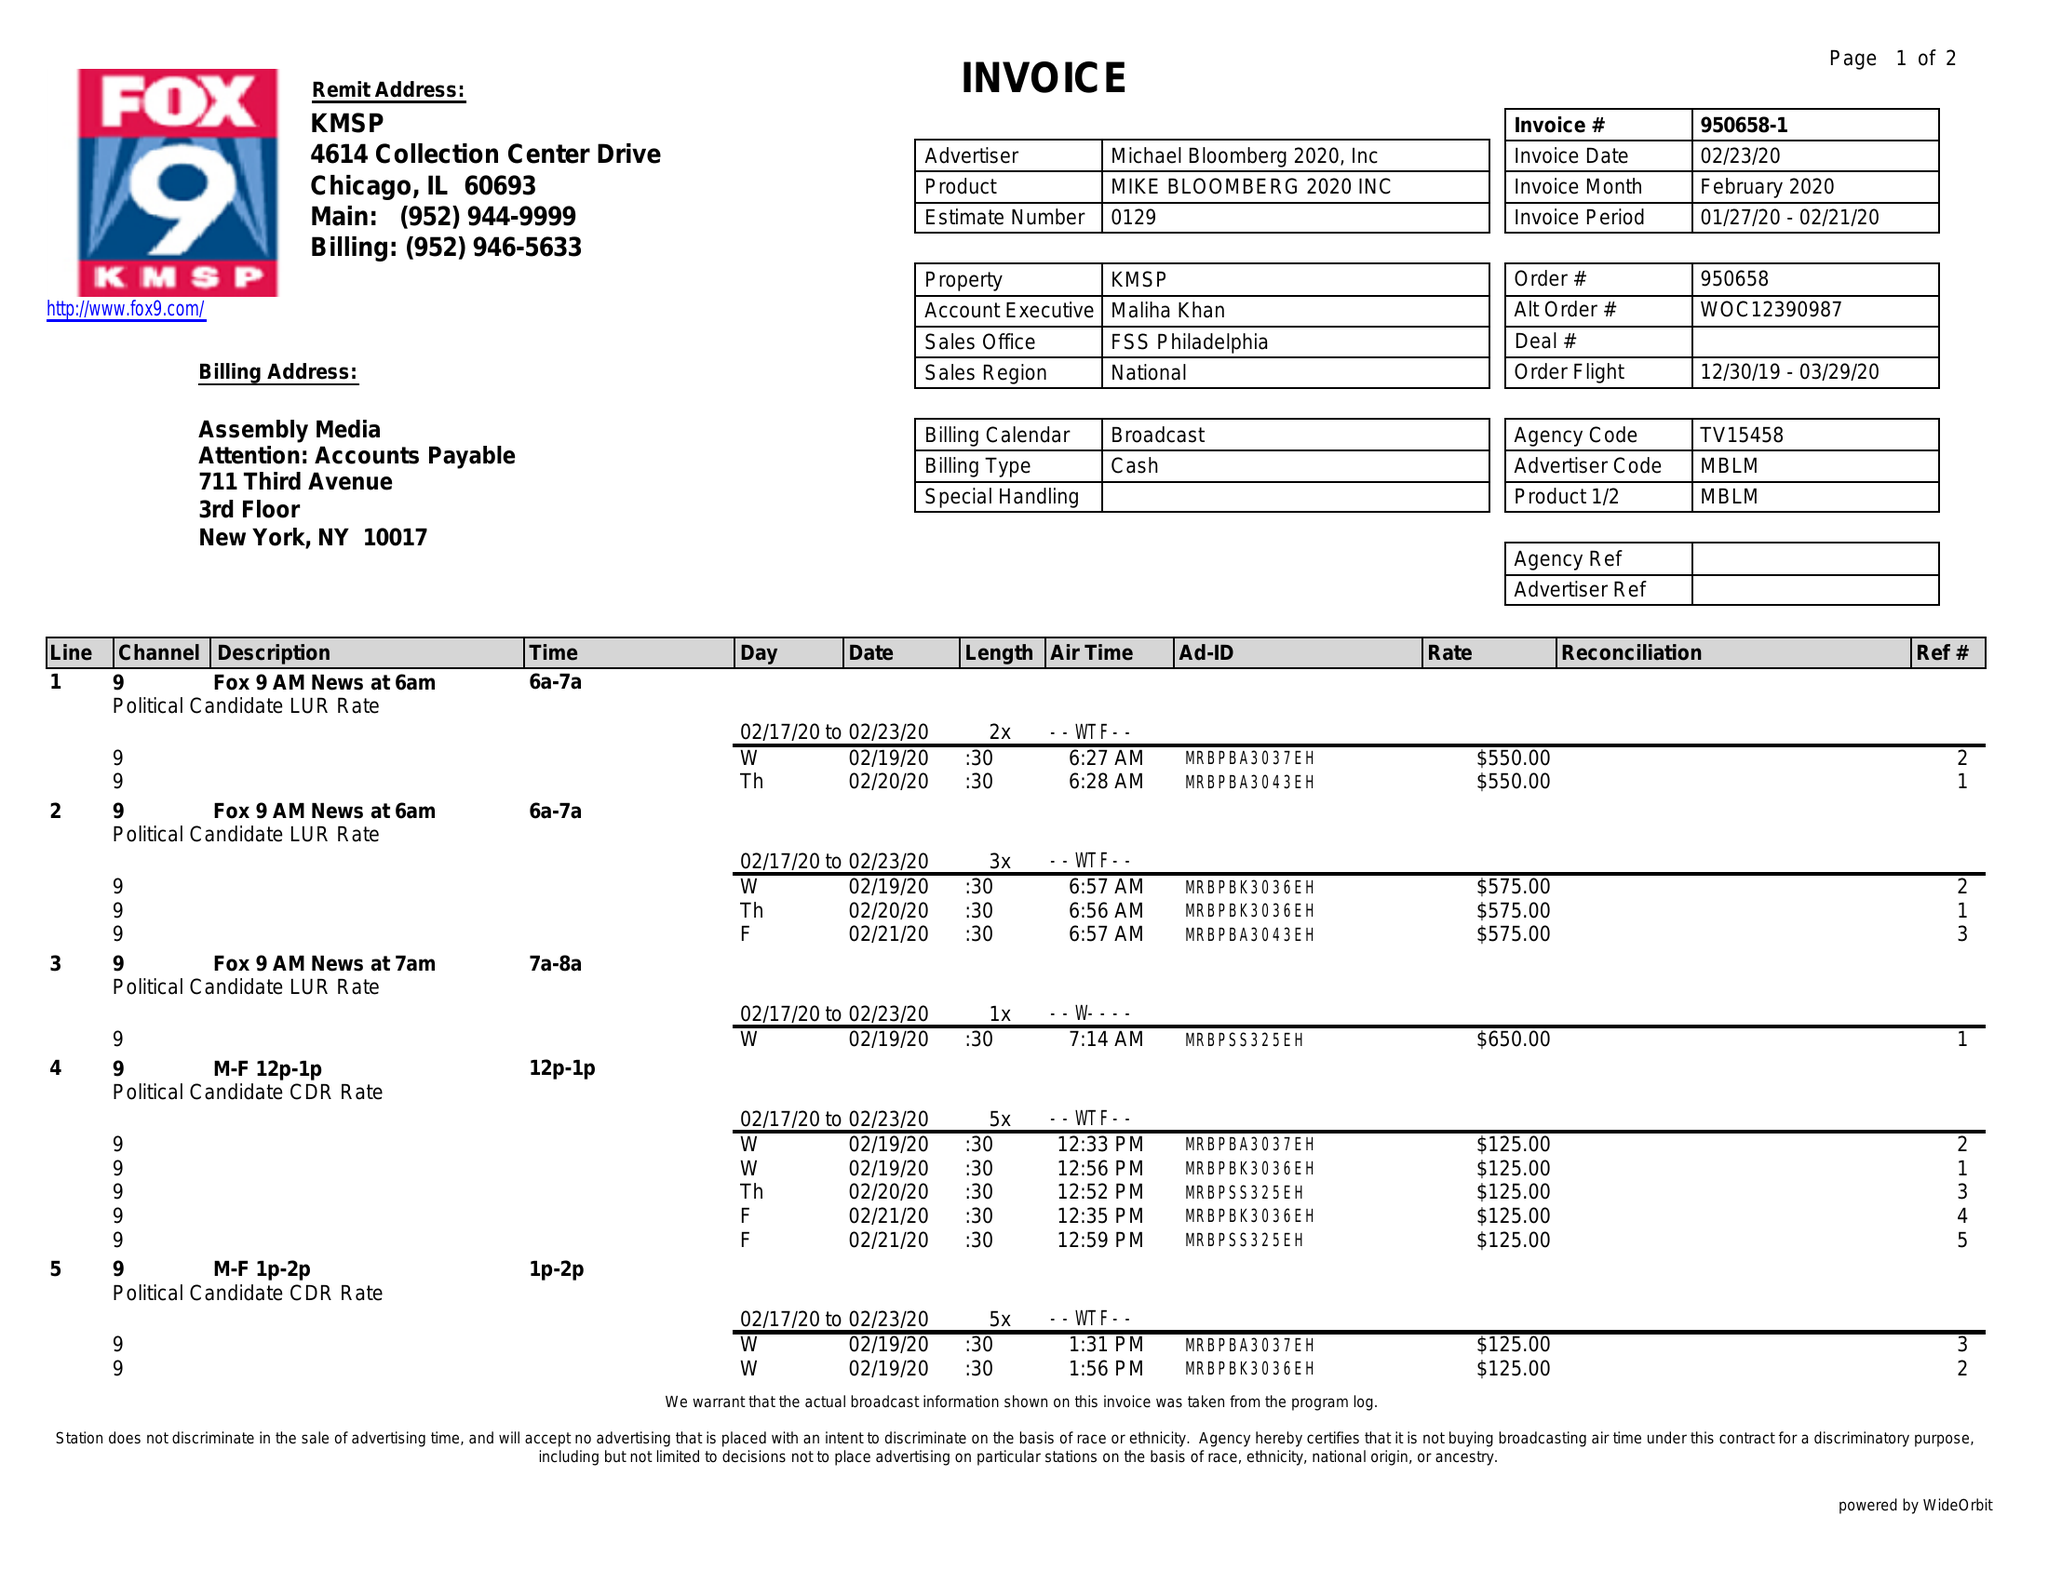What is the value for the contract_num?
Answer the question using a single word or phrase. 950658 